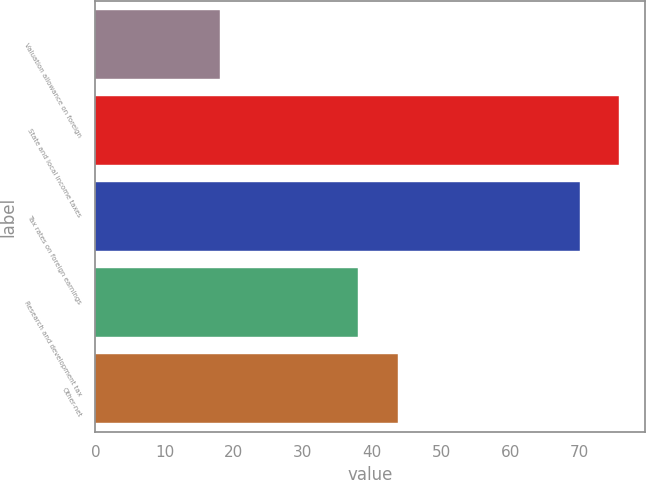Convert chart to OTSL. <chart><loc_0><loc_0><loc_500><loc_500><bar_chart><fcel>Valuation allowance on foreign<fcel>State and local income taxes<fcel>Tax rates on foreign earnings<fcel>Research and development tax<fcel>Other-net<nl><fcel>18<fcel>75.7<fcel>70<fcel>38<fcel>43.7<nl></chart> 